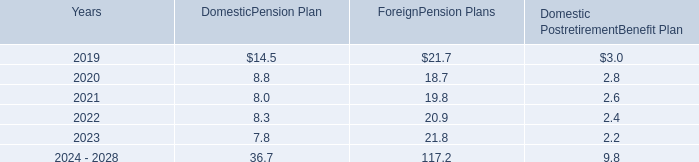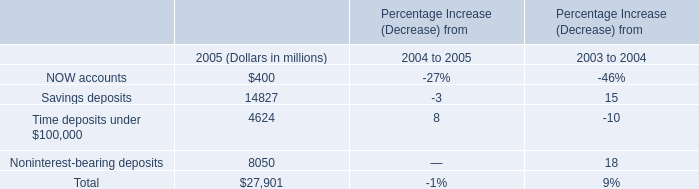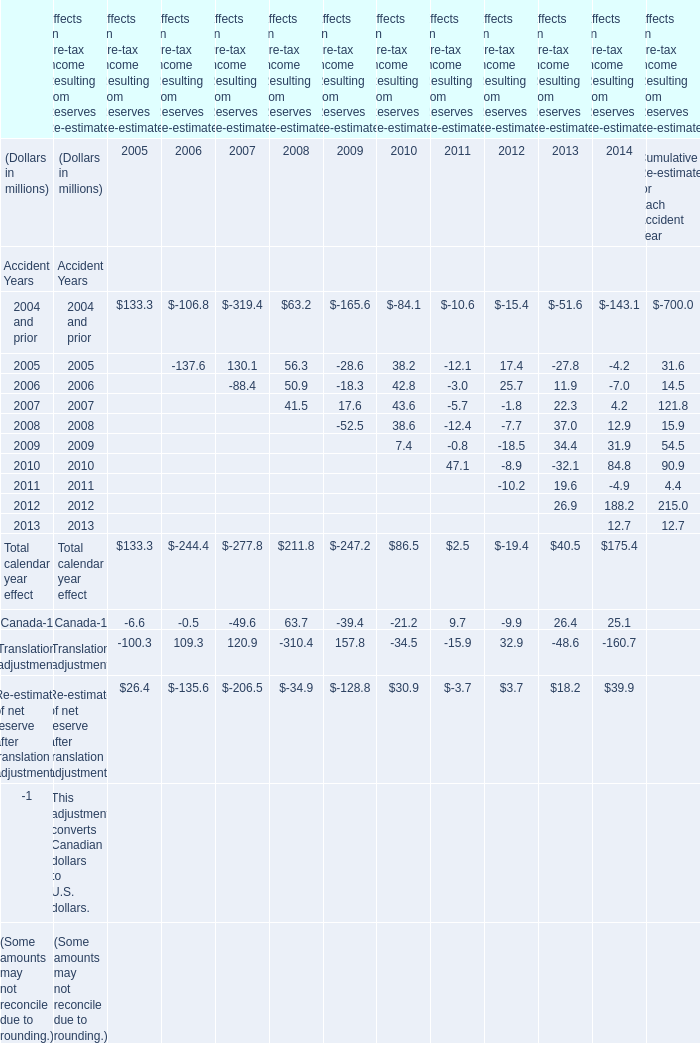what is the percentage decrease between the amounts expensed for deferred compensation and deferred benefit liability in 2017 and 2018? 
Computations: (((213.2 - 196.2) / 213.2) * 100)
Answer: 7.97373. 